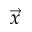<formula> <loc_0><loc_0><loc_500><loc_500>\vec { x }</formula> 